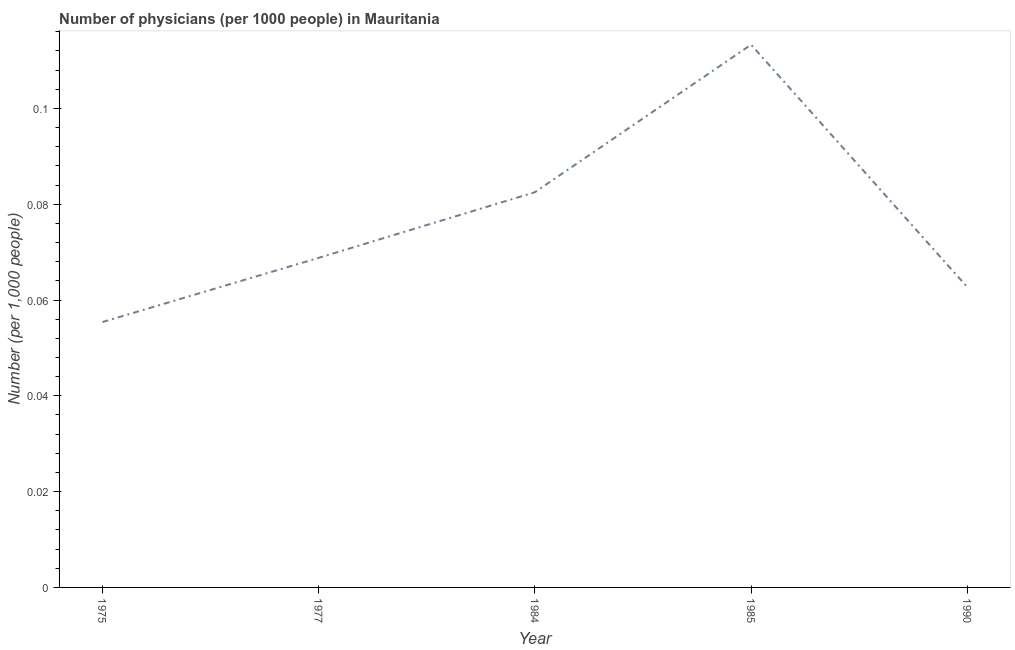What is the number of physicians in 1985?
Provide a succinct answer. 0.11. Across all years, what is the maximum number of physicians?
Offer a terse response. 0.11. Across all years, what is the minimum number of physicians?
Keep it short and to the point. 0.06. In which year was the number of physicians maximum?
Your response must be concise. 1985. In which year was the number of physicians minimum?
Your answer should be compact. 1975. What is the sum of the number of physicians?
Your answer should be very brief. 0.38. What is the difference between the number of physicians in 1984 and 1985?
Provide a succinct answer. -0.03. What is the average number of physicians per year?
Your response must be concise. 0.08. What is the median number of physicians?
Provide a succinct answer. 0.07. Do a majority of the years between 1990 and 1985 (inclusive) have number of physicians greater than 0.04 ?
Give a very brief answer. No. What is the ratio of the number of physicians in 1985 to that in 1990?
Offer a very short reply. 1.81. Is the difference between the number of physicians in 1977 and 1990 greater than the difference between any two years?
Your answer should be very brief. No. What is the difference between the highest and the second highest number of physicians?
Your answer should be very brief. 0.03. What is the difference between the highest and the lowest number of physicians?
Ensure brevity in your answer.  0.06. In how many years, is the number of physicians greater than the average number of physicians taken over all years?
Your response must be concise. 2. How many years are there in the graph?
Provide a short and direct response. 5. Does the graph contain any zero values?
Ensure brevity in your answer.  No. Does the graph contain grids?
Ensure brevity in your answer.  No. What is the title of the graph?
Provide a succinct answer. Number of physicians (per 1000 people) in Mauritania. What is the label or title of the X-axis?
Ensure brevity in your answer.  Year. What is the label or title of the Y-axis?
Offer a very short reply. Number (per 1,0 people). What is the Number (per 1,000 people) of 1975?
Keep it short and to the point. 0.06. What is the Number (per 1,000 people) of 1977?
Make the answer very short. 0.07. What is the Number (per 1,000 people) of 1984?
Offer a terse response. 0.08. What is the Number (per 1,000 people) in 1985?
Offer a terse response. 0.11. What is the Number (per 1,000 people) of 1990?
Ensure brevity in your answer.  0.06. What is the difference between the Number (per 1,000 people) in 1975 and 1977?
Keep it short and to the point. -0.01. What is the difference between the Number (per 1,000 people) in 1975 and 1984?
Offer a very short reply. -0.03. What is the difference between the Number (per 1,000 people) in 1975 and 1985?
Ensure brevity in your answer.  -0.06. What is the difference between the Number (per 1,000 people) in 1975 and 1990?
Your answer should be very brief. -0.01. What is the difference between the Number (per 1,000 people) in 1977 and 1984?
Ensure brevity in your answer.  -0.01. What is the difference between the Number (per 1,000 people) in 1977 and 1985?
Keep it short and to the point. -0.04. What is the difference between the Number (per 1,000 people) in 1977 and 1990?
Ensure brevity in your answer.  0.01. What is the difference between the Number (per 1,000 people) in 1984 and 1985?
Your answer should be very brief. -0.03. What is the difference between the Number (per 1,000 people) in 1984 and 1990?
Keep it short and to the point. 0.02. What is the difference between the Number (per 1,000 people) in 1985 and 1990?
Provide a succinct answer. 0.05. What is the ratio of the Number (per 1,000 people) in 1975 to that in 1977?
Keep it short and to the point. 0.81. What is the ratio of the Number (per 1,000 people) in 1975 to that in 1984?
Keep it short and to the point. 0.67. What is the ratio of the Number (per 1,000 people) in 1975 to that in 1985?
Your answer should be very brief. 0.49. What is the ratio of the Number (per 1,000 people) in 1975 to that in 1990?
Keep it short and to the point. 0.88. What is the ratio of the Number (per 1,000 people) in 1977 to that in 1984?
Offer a very short reply. 0.83. What is the ratio of the Number (per 1,000 people) in 1977 to that in 1985?
Provide a short and direct response. 0.61. What is the ratio of the Number (per 1,000 people) in 1977 to that in 1990?
Keep it short and to the point. 1.1. What is the ratio of the Number (per 1,000 people) in 1984 to that in 1985?
Offer a very short reply. 0.73. What is the ratio of the Number (per 1,000 people) in 1984 to that in 1990?
Your response must be concise. 1.32. What is the ratio of the Number (per 1,000 people) in 1985 to that in 1990?
Your answer should be very brief. 1.81. 